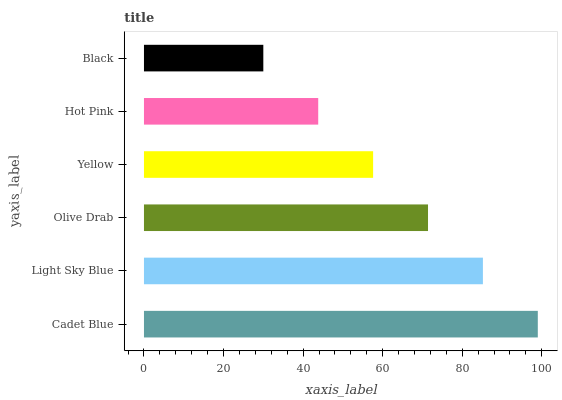Is Black the minimum?
Answer yes or no. Yes. Is Cadet Blue the maximum?
Answer yes or no. Yes. Is Light Sky Blue the minimum?
Answer yes or no. No. Is Light Sky Blue the maximum?
Answer yes or no. No. Is Cadet Blue greater than Light Sky Blue?
Answer yes or no. Yes. Is Light Sky Blue less than Cadet Blue?
Answer yes or no. Yes. Is Light Sky Blue greater than Cadet Blue?
Answer yes or no. No. Is Cadet Blue less than Light Sky Blue?
Answer yes or no. No. Is Olive Drab the high median?
Answer yes or no. Yes. Is Yellow the low median?
Answer yes or no. Yes. Is Yellow the high median?
Answer yes or no. No. Is Black the low median?
Answer yes or no. No. 